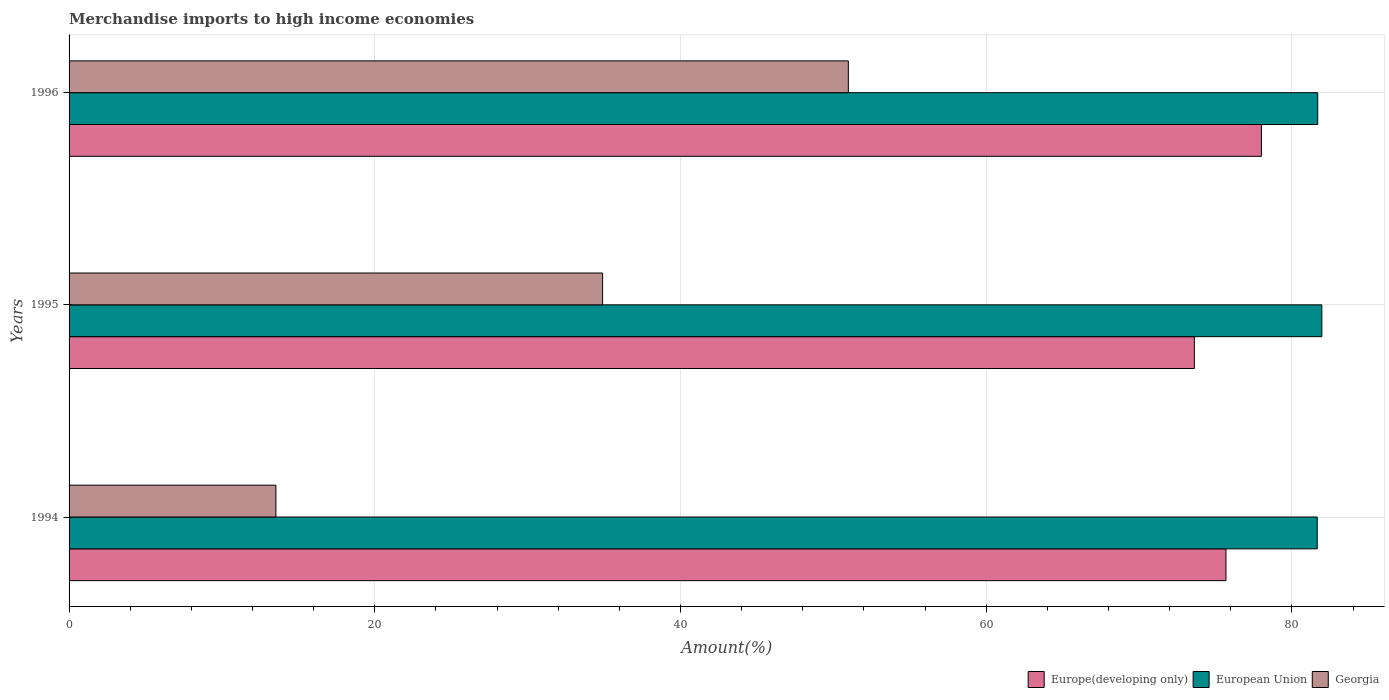How many groups of bars are there?
Keep it short and to the point. 3. Are the number of bars on each tick of the Y-axis equal?
Your answer should be compact. Yes. How many bars are there on the 1st tick from the bottom?
Ensure brevity in your answer.  3. In how many cases, is the number of bars for a given year not equal to the number of legend labels?
Keep it short and to the point. 0. What is the percentage of amount earned from merchandise imports in Georgia in 1995?
Your answer should be compact. 34.9. Across all years, what is the maximum percentage of amount earned from merchandise imports in Europe(developing only)?
Keep it short and to the point. 78. Across all years, what is the minimum percentage of amount earned from merchandise imports in Georgia?
Give a very brief answer. 13.53. In which year was the percentage of amount earned from merchandise imports in Europe(developing only) maximum?
Keep it short and to the point. 1996. What is the total percentage of amount earned from merchandise imports in European Union in the graph?
Offer a very short reply. 245.3. What is the difference between the percentage of amount earned from merchandise imports in Georgia in 1995 and that in 1996?
Offer a terse response. -16.08. What is the difference between the percentage of amount earned from merchandise imports in European Union in 1994 and the percentage of amount earned from merchandise imports in Georgia in 1996?
Offer a very short reply. 30.67. What is the average percentage of amount earned from merchandise imports in European Union per year?
Keep it short and to the point. 81.77. In the year 1994, what is the difference between the percentage of amount earned from merchandise imports in Georgia and percentage of amount earned from merchandise imports in European Union?
Your response must be concise. -68.12. In how many years, is the percentage of amount earned from merchandise imports in Georgia greater than 36 %?
Offer a very short reply. 1. What is the ratio of the percentage of amount earned from merchandise imports in Georgia in 1994 to that in 1996?
Provide a short and direct response. 0.27. Is the difference between the percentage of amount earned from merchandise imports in Georgia in 1994 and 1995 greater than the difference between the percentage of amount earned from merchandise imports in European Union in 1994 and 1995?
Keep it short and to the point. No. What is the difference between the highest and the second highest percentage of amount earned from merchandise imports in Georgia?
Offer a terse response. 16.08. What is the difference between the highest and the lowest percentage of amount earned from merchandise imports in Europe(developing only)?
Offer a very short reply. 4.38. What does the 3rd bar from the top in 1994 represents?
Give a very brief answer. Europe(developing only). What does the 3rd bar from the bottom in 1994 represents?
Offer a very short reply. Georgia. How many bars are there?
Keep it short and to the point. 9. Are the values on the major ticks of X-axis written in scientific E-notation?
Make the answer very short. No. Does the graph contain grids?
Provide a succinct answer. Yes. Where does the legend appear in the graph?
Make the answer very short. Bottom right. How are the legend labels stacked?
Keep it short and to the point. Horizontal. What is the title of the graph?
Your answer should be compact. Merchandise imports to high income economies. What is the label or title of the X-axis?
Your response must be concise. Amount(%). What is the label or title of the Y-axis?
Your answer should be compact. Years. What is the Amount(%) of Europe(developing only) in 1994?
Provide a short and direct response. 75.68. What is the Amount(%) in European Union in 1994?
Give a very brief answer. 81.65. What is the Amount(%) of Georgia in 1994?
Provide a short and direct response. 13.53. What is the Amount(%) of Europe(developing only) in 1995?
Keep it short and to the point. 73.62. What is the Amount(%) in European Union in 1995?
Your response must be concise. 81.96. What is the Amount(%) in Georgia in 1995?
Your response must be concise. 34.9. What is the Amount(%) of Europe(developing only) in 1996?
Offer a very short reply. 78. What is the Amount(%) in European Union in 1996?
Make the answer very short. 81.69. What is the Amount(%) in Georgia in 1996?
Your answer should be very brief. 50.98. Across all years, what is the maximum Amount(%) in Europe(developing only)?
Your answer should be compact. 78. Across all years, what is the maximum Amount(%) in European Union?
Provide a short and direct response. 81.96. Across all years, what is the maximum Amount(%) of Georgia?
Offer a terse response. 50.98. Across all years, what is the minimum Amount(%) in Europe(developing only)?
Give a very brief answer. 73.62. Across all years, what is the minimum Amount(%) in European Union?
Offer a terse response. 81.65. Across all years, what is the minimum Amount(%) in Georgia?
Make the answer very short. 13.53. What is the total Amount(%) of Europe(developing only) in the graph?
Your answer should be very brief. 227.3. What is the total Amount(%) in European Union in the graph?
Ensure brevity in your answer.  245.3. What is the total Amount(%) of Georgia in the graph?
Offer a very short reply. 99.42. What is the difference between the Amount(%) of Europe(developing only) in 1994 and that in 1995?
Offer a very short reply. 2.07. What is the difference between the Amount(%) of European Union in 1994 and that in 1995?
Ensure brevity in your answer.  -0.3. What is the difference between the Amount(%) of Georgia in 1994 and that in 1995?
Give a very brief answer. -21.37. What is the difference between the Amount(%) of Europe(developing only) in 1994 and that in 1996?
Provide a succinct answer. -2.32. What is the difference between the Amount(%) in European Union in 1994 and that in 1996?
Your answer should be very brief. -0.03. What is the difference between the Amount(%) of Georgia in 1994 and that in 1996?
Provide a short and direct response. -37.45. What is the difference between the Amount(%) in Europe(developing only) in 1995 and that in 1996?
Provide a succinct answer. -4.38. What is the difference between the Amount(%) in European Union in 1995 and that in 1996?
Offer a terse response. 0.27. What is the difference between the Amount(%) of Georgia in 1995 and that in 1996?
Give a very brief answer. -16.08. What is the difference between the Amount(%) of Europe(developing only) in 1994 and the Amount(%) of European Union in 1995?
Ensure brevity in your answer.  -6.27. What is the difference between the Amount(%) of Europe(developing only) in 1994 and the Amount(%) of Georgia in 1995?
Offer a terse response. 40.78. What is the difference between the Amount(%) in European Union in 1994 and the Amount(%) in Georgia in 1995?
Your response must be concise. 46.75. What is the difference between the Amount(%) of Europe(developing only) in 1994 and the Amount(%) of European Union in 1996?
Your answer should be very brief. -6. What is the difference between the Amount(%) in Europe(developing only) in 1994 and the Amount(%) in Georgia in 1996?
Ensure brevity in your answer.  24.7. What is the difference between the Amount(%) of European Union in 1994 and the Amount(%) of Georgia in 1996?
Give a very brief answer. 30.67. What is the difference between the Amount(%) in Europe(developing only) in 1995 and the Amount(%) in European Union in 1996?
Your answer should be very brief. -8.07. What is the difference between the Amount(%) in Europe(developing only) in 1995 and the Amount(%) in Georgia in 1996?
Give a very brief answer. 22.64. What is the difference between the Amount(%) of European Union in 1995 and the Amount(%) of Georgia in 1996?
Give a very brief answer. 30.98. What is the average Amount(%) in Europe(developing only) per year?
Ensure brevity in your answer.  75.77. What is the average Amount(%) in European Union per year?
Your response must be concise. 81.77. What is the average Amount(%) in Georgia per year?
Provide a short and direct response. 33.14. In the year 1994, what is the difference between the Amount(%) in Europe(developing only) and Amount(%) in European Union?
Make the answer very short. -5.97. In the year 1994, what is the difference between the Amount(%) of Europe(developing only) and Amount(%) of Georgia?
Make the answer very short. 62.15. In the year 1994, what is the difference between the Amount(%) in European Union and Amount(%) in Georgia?
Provide a succinct answer. 68.12. In the year 1995, what is the difference between the Amount(%) in Europe(developing only) and Amount(%) in European Union?
Your answer should be very brief. -8.34. In the year 1995, what is the difference between the Amount(%) of Europe(developing only) and Amount(%) of Georgia?
Your answer should be compact. 38.71. In the year 1995, what is the difference between the Amount(%) in European Union and Amount(%) in Georgia?
Keep it short and to the point. 47.05. In the year 1996, what is the difference between the Amount(%) in Europe(developing only) and Amount(%) in European Union?
Offer a very short reply. -3.68. In the year 1996, what is the difference between the Amount(%) in Europe(developing only) and Amount(%) in Georgia?
Give a very brief answer. 27.02. In the year 1996, what is the difference between the Amount(%) of European Union and Amount(%) of Georgia?
Provide a short and direct response. 30.71. What is the ratio of the Amount(%) of Europe(developing only) in 1994 to that in 1995?
Your answer should be very brief. 1.03. What is the ratio of the Amount(%) in European Union in 1994 to that in 1995?
Provide a succinct answer. 1. What is the ratio of the Amount(%) of Georgia in 1994 to that in 1995?
Provide a succinct answer. 0.39. What is the ratio of the Amount(%) in Europe(developing only) in 1994 to that in 1996?
Offer a terse response. 0.97. What is the ratio of the Amount(%) in Georgia in 1994 to that in 1996?
Keep it short and to the point. 0.27. What is the ratio of the Amount(%) of Europe(developing only) in 1995 to that in 1996?
Provide a short and direct response. 0.94. What is the ratio of the Amount(%) of European Union in 1995 to that in 1996?
Ensure brevity in your answer.  1. What is the ratio of the Amount(%) of Georgia in 1995 to that in 1996?
Your answer should be very brief. 0.68. What is the difference between the highest and the second highest Amount(%) of Europe(developing only)?
Ensure brevity in your answer.  2.32. What is the difference between the highest and the second highest Amount(%) of European Union?
Provide a succinct answer. 0.27. What is the difference between the highest and the second highest Amount(%) of Georgia?
Provide a succinct answer. 16.08. What is the difference between the highest and the lowest Amount(%) of Europe(developing only)?
Provide a short and direct response. 4.38. What is the difference between the highest and the lowest Amount(%) of European Union?
Ensure brevity in your answer.  0.3. What is the difference between the highest and the lowest Amount(%) in Georgia?
Keep it short and to the point. 37.45. 